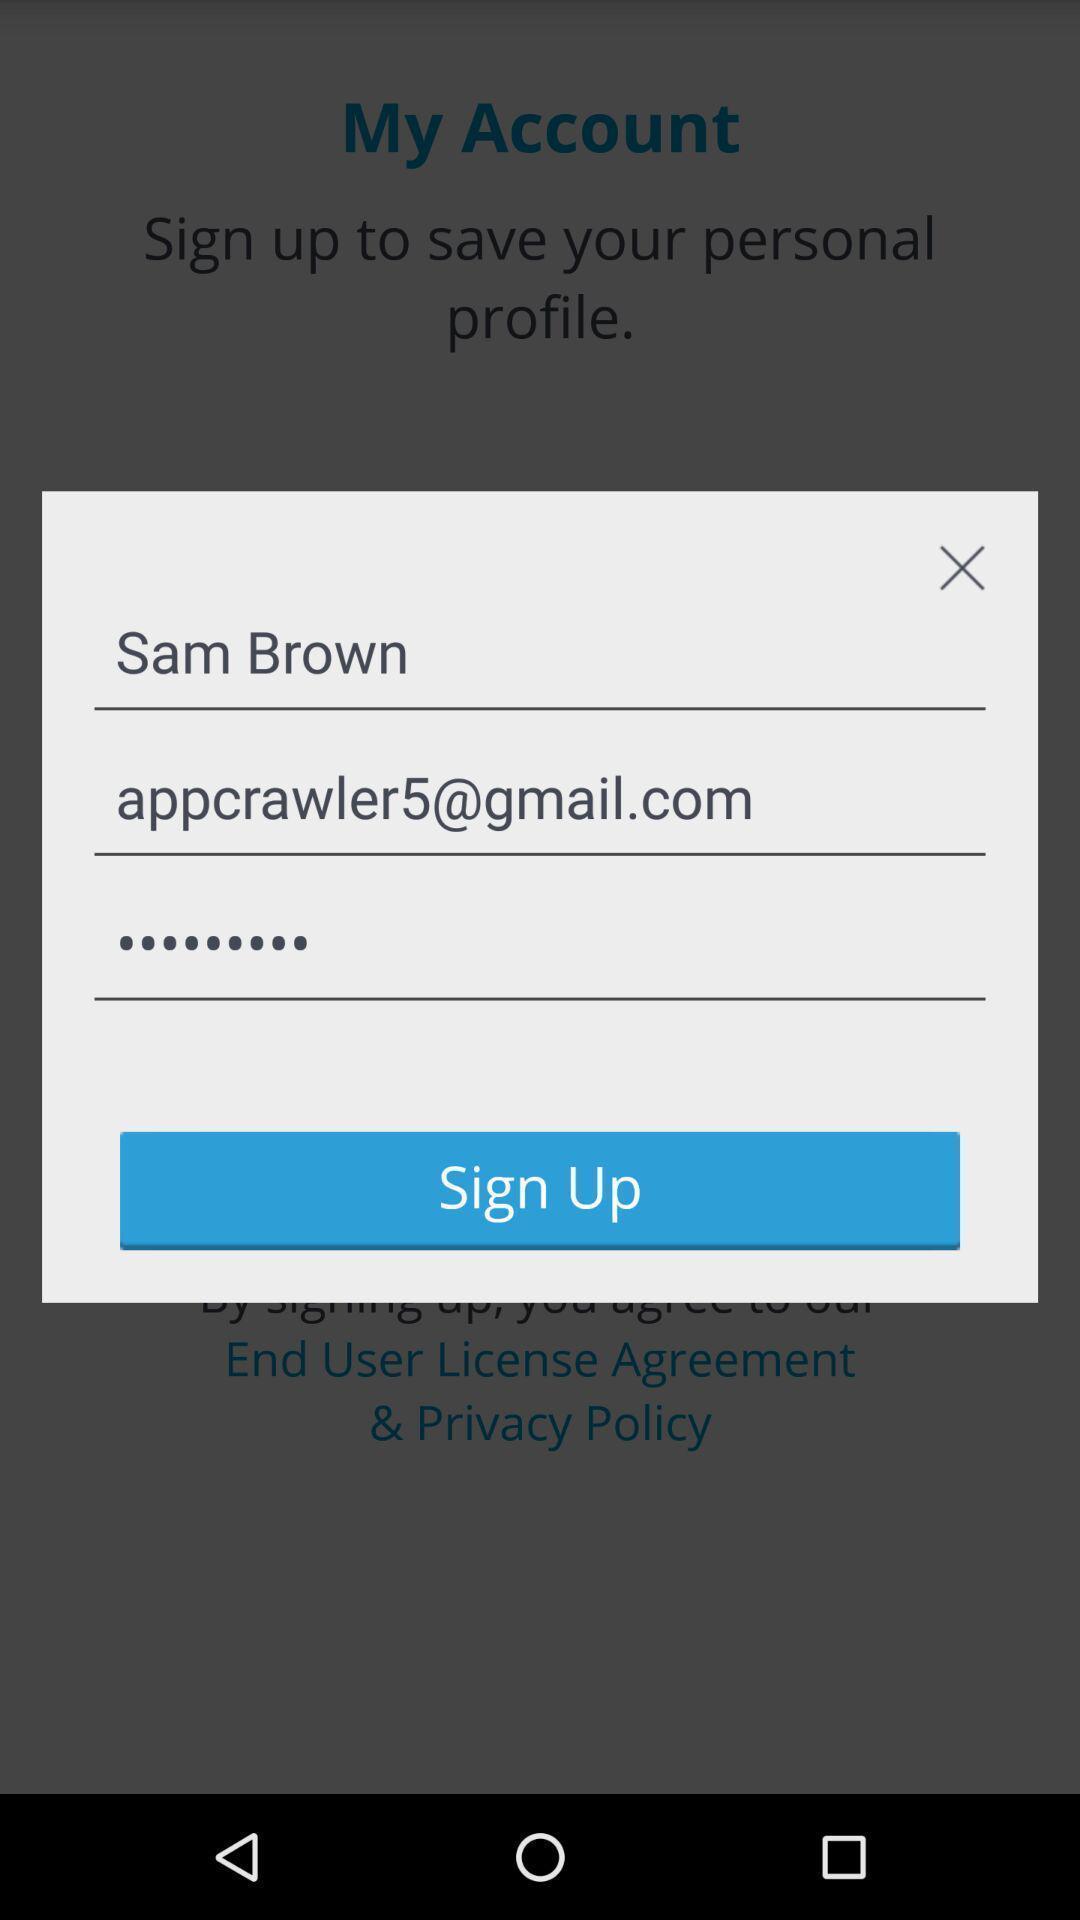What can you discern from this picture? Pop-up with fields to sign in to an account. 